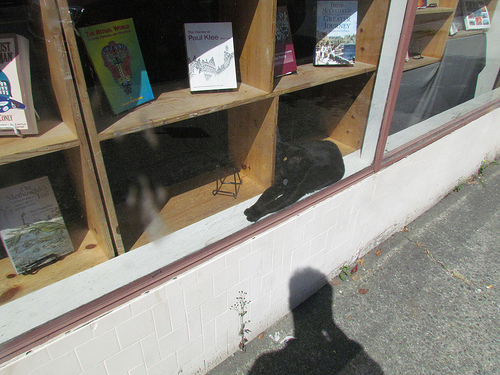<image>
Is the cat in the window? Yes. The cat is contained within or inside the window, showing a containment relationship. Is the cat in the ledge? Yes. The cat is contained within or inside the ledge, showing a containment relationship. 